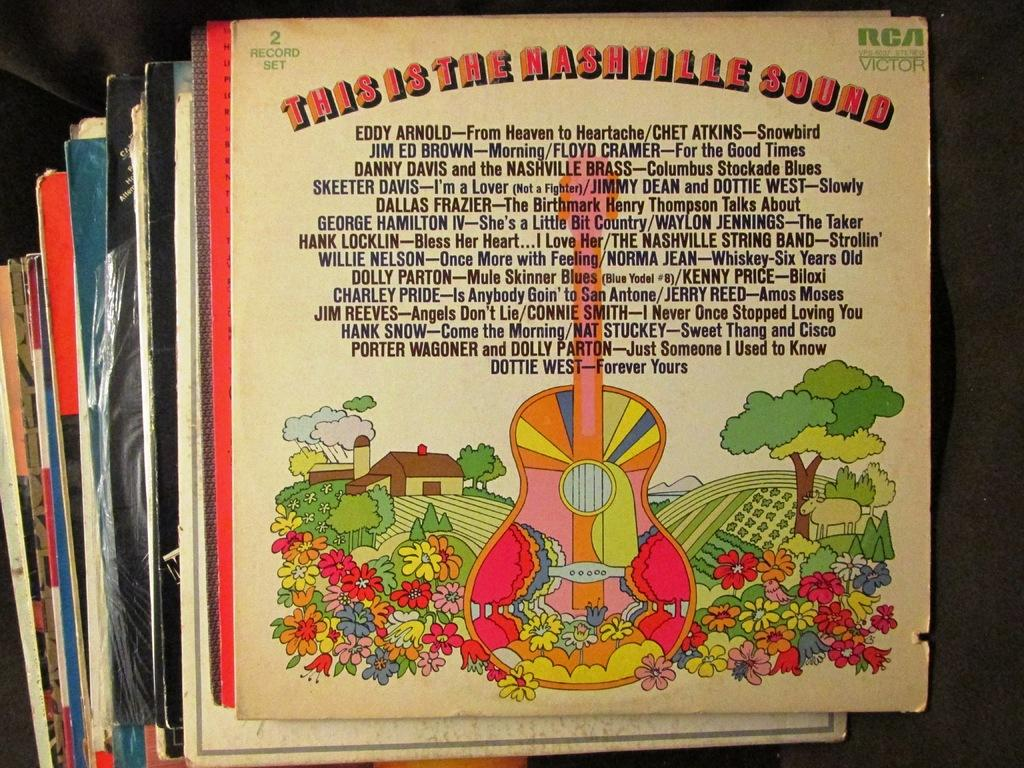<image>
Create a compact narrative representing the image presented. A stack of records in their sleeves, with the topmost record being This Is The Nashville Sound. 